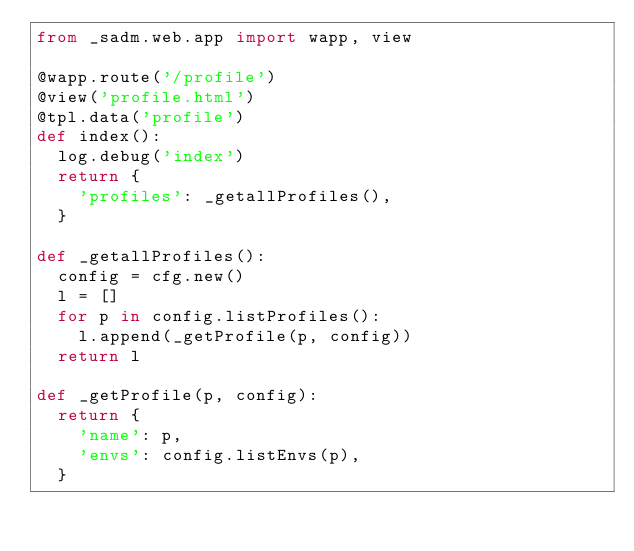<code> <loc_0><loc_0><loc_500><loc_500><_Python_>from _sadm.web.app import wapp, view

@wapp.route('/profile')
@view('profile.html')
@tpl.data('profile')
def index():
	log.debug('index')
	return {
		'profiles': _getallProfiles(),
	}

def _getallProfiles():
	config = cfg.new()
	l = []
	for p in config.listProfiles():
		l.append(_getProfile(p, config))
	return l

def _getProfile(p, config):
	return {
		'name': p,
		'envs': config.listEnvs(p),
	}
</code> 